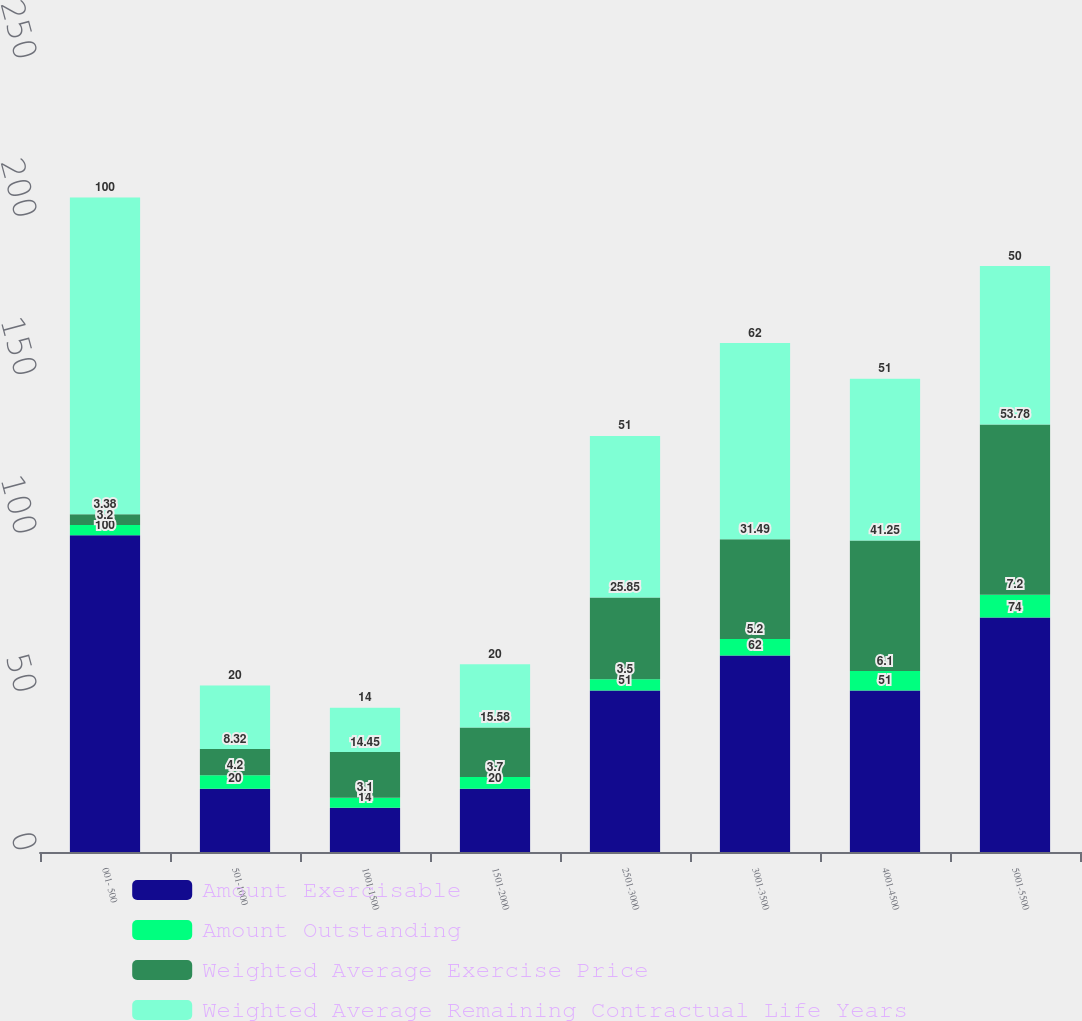<chart> <loc_0><loc_0><loc_500><loc_500><stacked_bar_chart><ecel><fcel>001- 500<fcel>501-1000<fcel>1001-1500<fcel>1501-2000<fcel>2501-3000<fcel>3001-3500<fcel>4001-4500<fcel>5001-5500<nl><fcel>Amount Exercisable<fcel>100<fcel>20<fcel>14<fcel>20<fcel>51<fcel>62<fcel>51<fcel>74<nl><fcel>Amount Outstanding<fcel>3.2<fcel>4.2<fcel>3.1<fcel>3.7<fcel>3.5<fcel>5.2<fcel>6.1<fcel>7.2<nl><fcel>Weighted Average Exercise Price<fcel>3.38<fcel>8.32<fcel>14.45<fcel>15.58<fcel>25.85<fcel>31.49<fcel>41.25<fcel>53.78<nl><fcel>Weighted Average Remaining Contractual Life Years<fcel>100<fcel>20<fcel>14<fcel>20<fcel>51<fcel>62<fcel>51<fcel>50<nl></chart> 